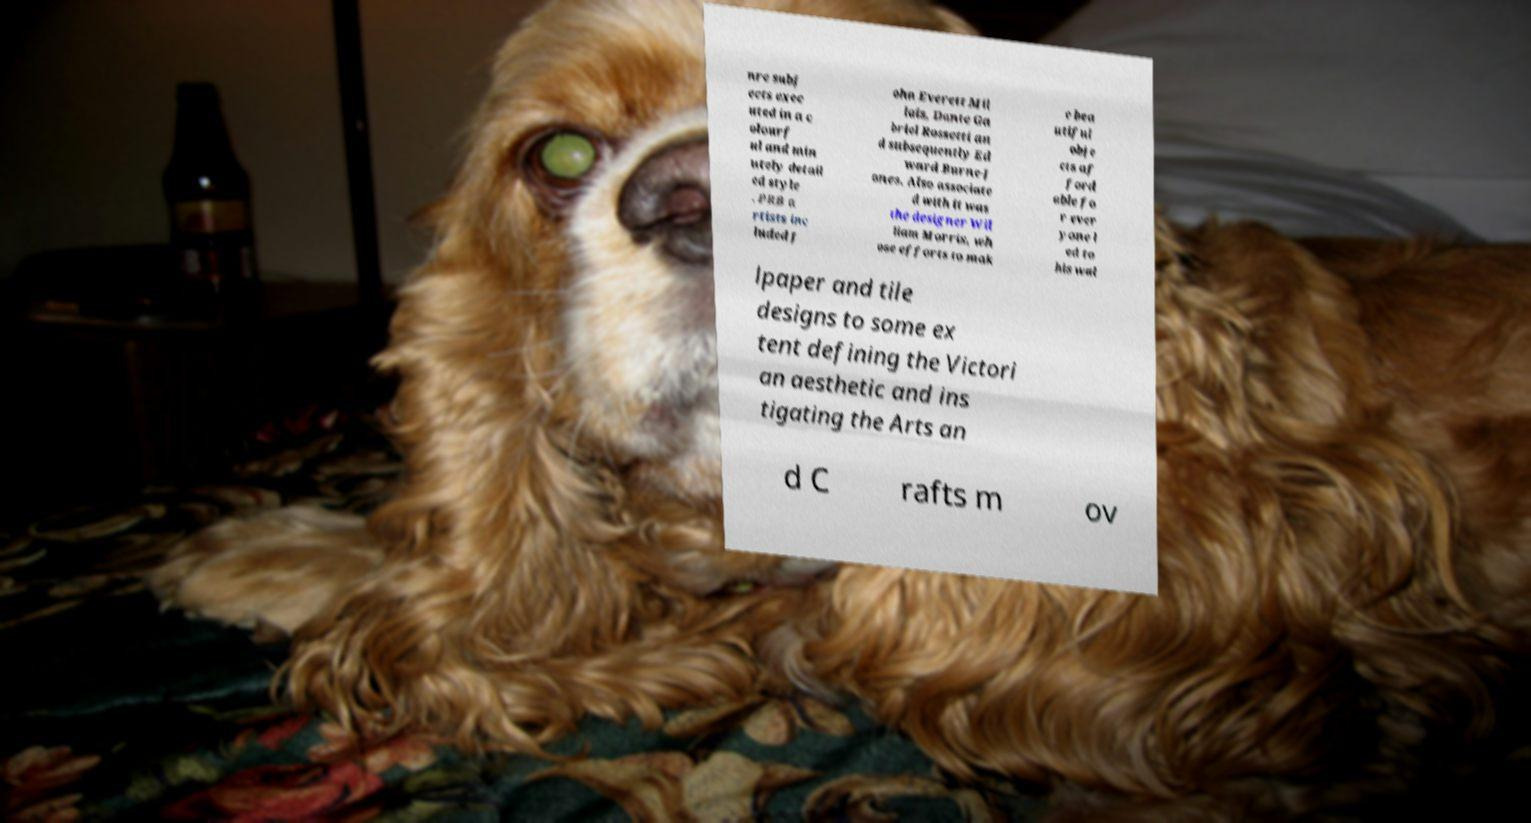Please identify and transcribe the text found in this image. nre subj ects exec uted in a c olourf ul and min utely detail ed style . PRB a rtists inc luded J ohn Everett Mil lais, Dante Ga briel Rossetti an d subsequently Ed ward Burne-J ones. Also associate d with it was the designer Wil liam Morris, wh ose efforts to mak e bea utiful obje cts af ford able fo r ever yone l ed to his wal lpaper and tile designs to some ex tent defining the Victori an aesthetic and ins tigating the Arts an d C rafts m ov 